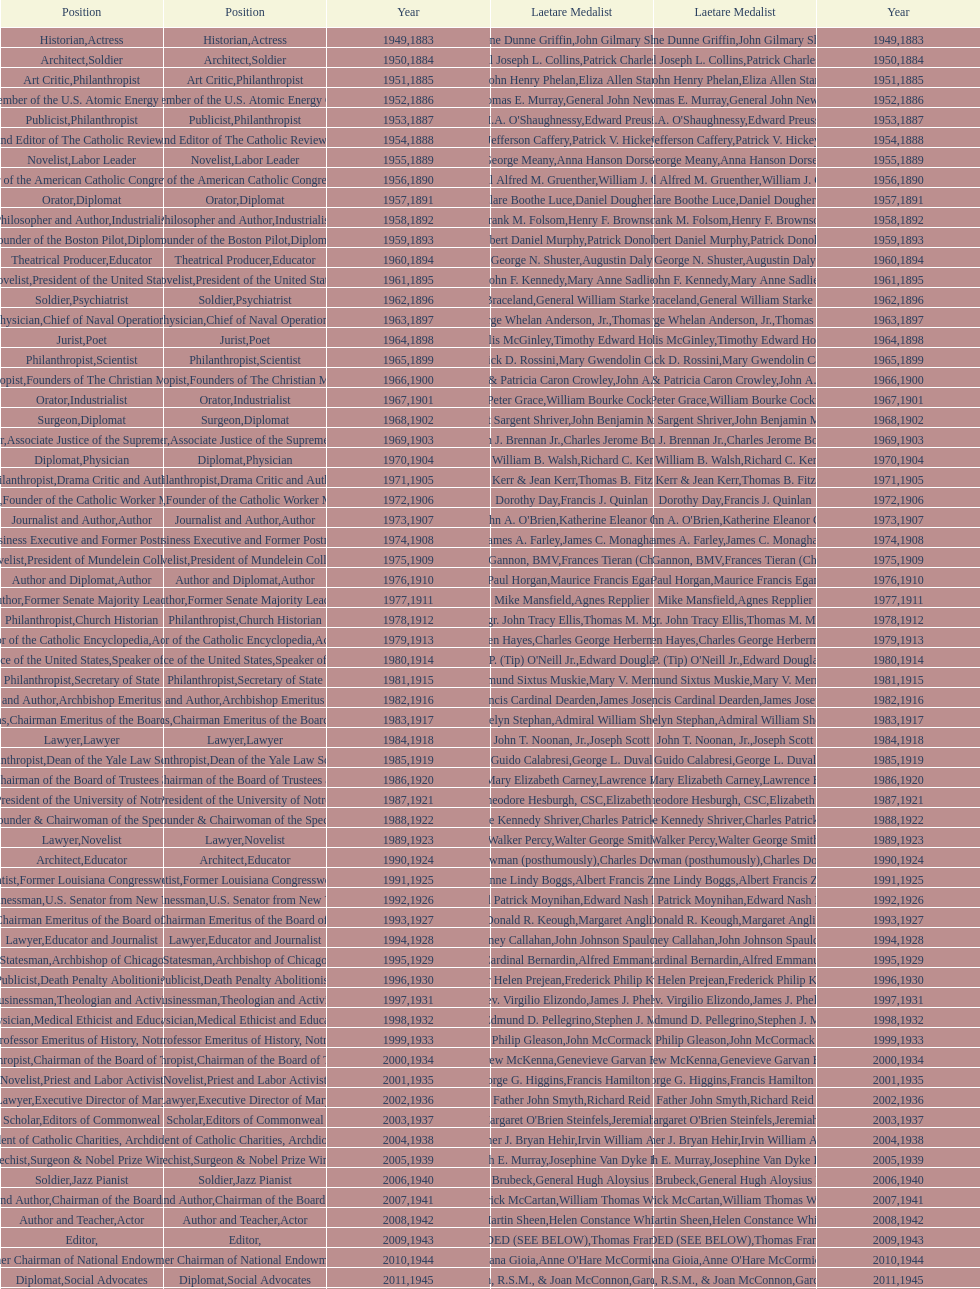How many times does philanthropist appear in the position column on this chart? 9. 